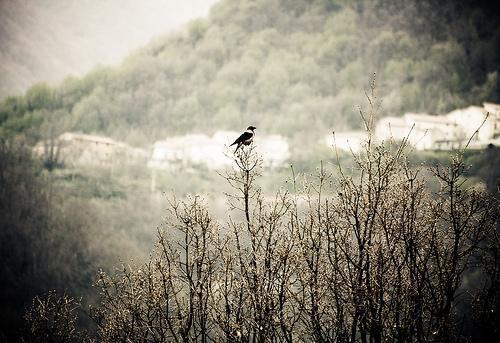How many animals are in the picture?
Give a very brief answer. 1. How many homes are on the right side of the bird?
Give a very brief answer. 4. 